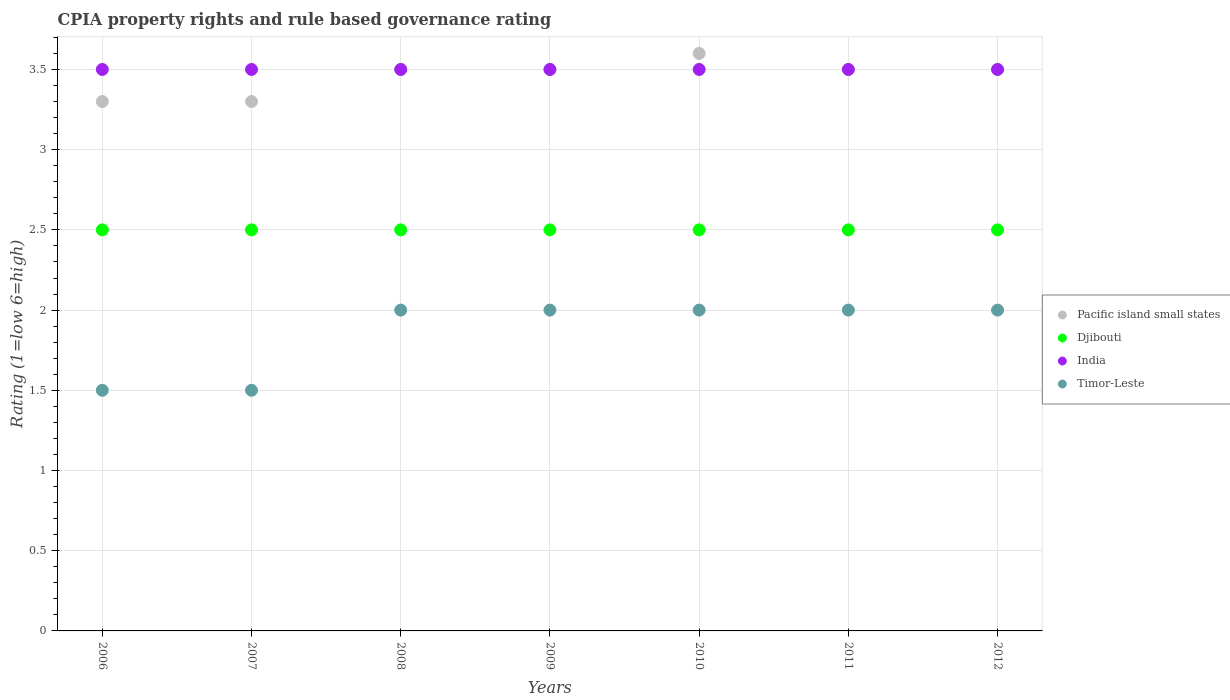Is the number of dotlines equal to the number of legend labels?
Your response must be concise. Yes. Across all years, what is the minimum CPIA rating in Djibouti?
Ensure brevity in your answer.  2.5. In which year was the CPIA rating in Pacific island small states minimum?
Offer a terse response. 2006. What is the total CPIA rating in Pacific island small states in the graph?
Your response must be concise. 24.2. What is the difference between the CPIA rating in India in 2010 and that in 2011?
Provide a succinct answer. 0. What is the difference between the CPIA rating in Timor-Leste in 2012 and the CPIA rating in Pacific island small states in 2007?
Ensure brevity in your answer.  -1.3. In how many years, is the CPIA rating in India greater than 2.4?
Make the answer very short. 7. What is the ratio of the CPIA rating in Timor-Leste in 2006 to that in 2011?
Offer a terse response. 0.75. Is the CPIA rating in India in 2008 less than that in 2011?
Ensure brevity in your answer.  No. What is the difference between the highest and the second highest CPIA rating in Pacific island small states?
Keep it short and to the point. 0.1. In how many years, is the CPIA rating in India greater than the average CPIA rating in India taken over all years?
Keep it short and to the point. 0. Is the sum of the CPIA rating in India in 2006 and 2008 greater than the maximum CPIA rating in Timor-Leste across all years?
Your answer should be compact. Yes. Is it the case that in every year, the sum of the CPIA rating in Timor-Leste and CPIA rating in Pacific island small states  is greater than the sum of CPIA rating in Djibouti and CPIA rating in India?
Your response must be concise. No. Is it the case that in every year, the sum of the CPIA rating in Timor-Leste and CPIA rating in Djibouti  is greater than the CPIA rating in India?
Keep it short and to the point. Yes. Is the CPIA rating in Djibouti strictly greater than the CPIA rating in Pacific island small states over the years?
Give a very brief answer. No. Is the CPIA rating in Timor-Leste strictly less than the CPIA rating in India over the years?
Give a very brief answer. Yes. How many years are there in the graph?
Offer a very short reply. 7. Are the values on the major ticks of Y-axis written in scientific E-notation?
Provide a succinct answer. No. Does the graph contain any zero values?
Offer a terse response. No. Where does the legend appear in the graph?
Provide a succinct answer. Center right. What is the title of the graph?
Make the answer very short. CPIA property rights and rule based governance rating. Does "South Sudan" appear as one of the legend labels in the graph?
Give a very brief answer. No. What is the Rating (1=low 6=high) of Pacific island small states in 2006?
Ensure brevity in your answer.  3.3. What is the Rating (1=low 6=high) of Timor-Leste in 2006?
Offer a very short reply. 1.5. What is the Rating (1=low 6=high) in Djibouti in 2007?
Your answer should be compact. 2.5. What is the Rating (1=low 6=high) in India in 2007?
Give a very brief answer. 3.5. What is the Rating (1=low 6=high) of Timor-Leste in 2007?
Give a very brief answer. 1.5. What is the Rating (1=low 6=high) of Djibouti in 2008?
Your answer should be compact. 2.5. What is the Rating (1=low 6=high) of India in 2008?
Your response must be concise. 3.5. What is the Rating (1=low 6=high) of Timor-Leste in 2008?
Offer a terse response. 2. What is the Rating (1=low 6=high) in Pacific island small states in 2009?
Your answer should be compact. 3.5. What is the Rating (1=low 6=high) in India in 2009?
Offer a very short reply. 3.5. What is the Rating (1=low 6=high) of Timor-Leste in 2010?
Offer a very short reply. 2. What is the Rating (1=low 6=high) of Pacific island small states in 2011?
Your answer should be compact. 3.5. What is the Rating (1=low 6=high) of India in 2011?
Offer a terse response. 3.5. What is the Rating (1=low 6=high) of Timor-Leste in 2011?
Provide a short and direct response. 2. What is the Rating (1=low 6=high) in Timor-Leste in 2012?
Ensure brevity in your answer.  2. Across all years, what is the maximum Rating (1=low 6=high) in India?
Provide a succinct answer. 3.5. What is the total Rating (1=low 6=high) of Pacific island small states in the graph?
Make the answer very short. 24.2. What is the total Rating (1=low 6=high) of Djibouti in the graph?
Provide a succinct answer. 17.5. What is the total Rating (1=low 6=high) in India in the graph?
Give a very brief answer. 24.5. What is the total Rating (1=low 6=high) of Timor-Leste in the graph?
Offer a very short reply. 13. What is the difference between the Rating (1=low 6=high) of India in 2006 and that in 2008?
Ensure brevity in your answer.  0. What is the difference between the Rating (1=low 6=high) in Pacific island small states in 2006 and that in 2009?
Your answer should be compact. -0.2. What is the difference between the Rating (1=low 6=high) of India in 2006 and that in 2009?
Your answer should be very brief. 0. What is the difference between the Rating (1=low 6=high) in Pacific island small states in 2006 and that in 2010?
Your answer should be compact. -0.3. What is the difference between the Rating (1=low 6=high) of Djibouti in 2006 and that in 2010?
Ensure brevity in your answer.  0. What is the difference between the Rating (1=low 6=high) in Pacific island small states in 2006 and that in 2011?
Make the answer very short. -0.2. What is the difference between the Rating (1=low 6=high) of Djibouti in 2006 and that in 2011?
Your answer should be compact. 0. What is the difference between the Rating (1=low 6=high) in India in 2006 and that in 2011?
Offer a very short reply. 0. What is the difference between the Rating (1=low 6=high) in Djibouti in 2006 and that in 2012?
Keep it short and to the point. 0. What is the difference between the Rating (1=low 6=high) of India in 2006 and that in 2012?
Offer a terse response. 0. What is the difference between the Rating (1=low 6=high) of Timor-Leste in 2006 and that in 2012?
Provide a succinct answer. -0.5. What is the difference between the Rating (1=low 6=high) in Pacific island small states in 2007 and that in 2008?
Your answer should be very brief. -0.2. What is the difference between the Rating (1=low 6=high) of India in 2007 and that in 2008?
Provide a short and direct response. 0. What is the difference between the Rating (1=low 6=high) in India in 2007 and that in 2009?
Provide a short and direct response. 0. What is the difference between the Rating (1=low 6=high) of Pacific island small states in 2007 and that in 2010?
Give a very brief answer. -0.3. What is the difference between the Rating (1=low 6=high) in Djibouti in 2007 and that in 2010?
Your answer should be compact. 0. What is the difference between the Rating (1=low 6=high) of India in 2007 and that in 2010?
Your answer should be compact. 0. What is the difference between the Rating (1=low 6=high) of Pacific island small states in 2007 and that in 2011?
Offer a terse response. -0.2. What is the difference between the Rating (1=low 6=high) of Djibouti in 2007 and that in 2011?
Provide a succinct answer. 0. What is the difference between the Rating (1=low 6=high) of Pacific island small states in 2007 and that in 2012?
Make the answer very short. -0.2. What is the difference between the Rating (1=low 6=high) of India in 2007 and that in 2012?
Offer a very short reply. 0. What is the difference between the Rating (1=low 6=high) of Timor-Leste in 2007 and that in 2012?
Your answer should be very brief. -0.5. What is the difference between the Rating (1=low 6=high) in Pacific island small states in 2008 and that in 2009?
Ensure brevity in your answer.  0. What is the difference between the Rating (1=low 6=high) of Djibouti in 2008 and that in 2009?
Make the answer very short. 0. What is the difference between the Rating (1=low 6=high) in India in 2008 and that in 2009?
Keep it short and to the point. 0. What is the difference between the Rating (1=low 6=high) of Timor-Leste in 2008 and that in 2009?
Ensure brevity in your answer.  0. What is the difference between the Rating (1=low 6=high) of Djibouti in 2008 and that in 2010?
Give a very brief answer. 0. What is the difference between the Rating (1=low 6=high) in Pacific island small states in 2008 and that in 2011?
Provide a short and direct response. 0. What is the difference between the Rating (1=low 6=high) of Djibouti in 2008 and that in 2011?
Your response must be concise. 0. What is the difference between the Rating (1=low 6=high) of India in 2008 and that in 2011?
Make the answer very short. 0. What is the difference between the Rating (1=low 6=high) in Pacific island small states in 2008 and that in 2012?
Your response must be concise. 0. What is the difference between the Rating (1=low 6=high) in Djibouti in 2008 and that in 2012?
Provide a short and direct response. 0. What is the difference between the Rating (1=low 6=high) in Pacific island small states in 2009 and that in 2011?
Offer a terse response. 0. What is the difference between the Rating (1=low 6=high) of Djibouti in 2009 and that in 2011?
Give a very brief answer. 0. What is the difference between the Rating (1=low 6=high) of India in 2009 and that in 2011?
Make the answer very short. 0. What is the difference between the Rating (1=low 6=high) of Pacific island small states in 2009 and that in 2012?
Make the answer very short. 0. What is the difference between the Rating (1=low 6=high) of Djibouti in 2009 and that in 2012?
Your response must be concise. 0. What is the difference between the Rating (1=low 6=high) of Timor-Leste in 2009 and that in 2012?
Provide a succinct answer. 0. What is the difference between the Rating (1=low 6=high) of Pacific island small states in 2010 and that in 2011?
Offer a very short reply. 0.1. What is the difference between the Rating (1=low 6=high) in Timor-Leste in 2010 and that in 2011?
Offer a very short reply. 0. What is the difference between the Rating (1=low 6=high) of Pacific island small states in 2010 and that in 2012?
Your answer should be compact. 0.1. What is the difference between the Rating (1=low 6=high) in Djibouti in 2010 and that in 2012?
Keep it short and to the point. 0. What is the difference between the Rating (1=low 6=high) of India in 2010 and that in 2012?
Your response must be concise. 0. What is the difference between the Rating (1=low 6=high) of Timor-Leste in 2010 and that in 2012?
Offer a terse response. 0. What is the difference between the Rating (1=low 6=high) of Pacific island small states in 2011 and that in 2012?
Provide a succinct answer. 0. What is the difference between the Rating (1=low 6=high) of India in 2011 and that in 2012?
Provide a short and direct response. 0. What is the difference between the Rating (1=low 6=high) of Pacific island small states in 2006 and the Rating (1=low 6=high) of Djibouti in 2007?
Offer a terse response. 0.8. What is the difference between the Rating (1=low 6=high) of Pacific island small states in 2006 and the Rating (1=low 6=high) of India in 2007?
Keep it short and to the point. -0.2. What is the difference between the Rating (1=low 6=high) in Djibouti in 2006 and the Rating (1=low 6=high) in India in 2007?
Ensure brevity in your answer.  -1. What is the difference between the Rating (1=low 6=high) of Djibouti in 2006 and the Rating (1=low 6=high) of Timor-Leste in 2008?
Keep it short and to the point. 0.5. What is the difference between the Rating (1=low 6=high) of Djibouti in 2006 and the Rating (1=low 6=high) of Timor-Leste in 2009?
Provide a short and direct response. 0.5. What is the difference between the Rating (1=low 6=high) of India in 2006 and the Rating (1=low 6=high) of Timor-Leste in 2009?
Ensure brevity in your answer.  1.5. What is the difference between the Rating (1=low 6=high) of Pacific island small states in 2006 and the Rating (1=low 6=high) of Djibouti in 2010?
Ensure brevity in your answer.  0.8. What is the difference between the Rating (1=low 6=high) in Pacific island small states in 2006 and the Rating (1=low 6=high) in Djibouti in 2011?
Provide a short and direct response. 0.8. What is the difference between the Rating (1=low 6=high) of Pacific island small states in 2006 and the Rating (1=low 6=high) of India in 2011?
Keep it short and to the point. -0.2. What is the difference between the Rating (1=low 6=high) of Djibouti in 2006 and the Rating (1=low 6=high) of Timor-Leste in 2011?
Provide a succinct answer. 0.5. What is the difference between the Rating (1=low 6=high) in Pacific island small states in 2006 and the Rating (1=low 6=high) in Djibouti in 2012?
Provide a succinct answer. 0.8. What is the difference between the Rating (1=low 6=high) of Pacific island small states in 2006 and the Rating (1=low 6=high) of India in 2012?
Ensure brevity in your answer.  -0.2. What is the difference between the Rating (1=low 6=high) in Djibouti in 2006 and the Rating (1=low 6=high) in India in 2012?
Provide a succinct answer. -1. What is the difference between the Rating (1=low 6=high) of Djibouti in 2006 and the Rating (1=low 6=high) of Timor-Leste in 2012?
Ensure brevity in your answer.  0.5. What is the difference between the Rating (1=low 6=high) of India in 2006 and the Rating (1=low 6=high) of Timor-Leste in 2012?
Keep it short and to the point. 1.5. What is the difference between the Rating (1=low 6=high) of Pacific island small states in 2007 and the Rating (1=low 6=high) of Djibouti in 2008?
Provide a succinct answer. 0.8. What is the difference between the Rating (1=low 6=high) of Djibouti in 2007 and the Rating (1=low 6=high) of Timor-Leste in 2008?
Keep it short and to the point. 0.5. What is the difference between the Rating (1=low 6=high) of Pacific island small states in 2007 and the Rating (1=low 6=high) of Timor-Leste in 2009?
Provide a short and direct response. 1.3. What is the difference between the Rating (1=low 6=high) in Pacific island small states in 2007 and the Rating (1=low 6=high) in Djibouti in 2010?
Keep it short and to the point. 0.8. What is the difference between the Rating (1=low 6=high) in Pacific island small states in 2007 and the Rating (1=low 6=high) in India in 2010?
Your response must be concise. -0.2. What is the difference between the Rating (1=low 6=high) of Djibouti in 2007 and the Rating (1=low 6=high) of India in 2010?
Offer a terse response. -1. What is the difference between the Rating (1=low 6=high) in Djibouti in 2007 and the Rating (1=low 6=high) in Timor-Leste in 2010?
Provide a short and direct response. 0.5. What is the difference between the Rating (1=low 6=high) in India in 2007 and the Rating (1=low 6=high) in Timor-Leste in 2010?
Your answer should be compact. 1.5. What is the difference between the Rating (1=low 6=high) of Pacific island small states in 2007 and the Rating (1=low 6=high) of Djibouti in 2012?
Your answer should be compact. 0.8. What is the difference between the Rating (1=low 6=high) of Pacific island small states in 2007 and the Rating (1=low 6=high) of India in 2012?
Ensure brevity in your answer.  -0.2. What is the difference between the Rating (1=low 6=high) of India in 2007 and the Rating (1=low 6=high) of Timor-Leste in 2012?
Make the answer very short. 1.5. What is the difference between the Rating (1=low 6=high) in Pacific island small states in 2008 and the Rating (1=low 6=high) in Djibouti in 2009?
Your answer should be very brief. 1. What is the difference between the Rating (1=low 6=high) of Pacific island small states in 2008 and the Rating (1=low 6=high) of Timor-Leste in 2009?
Ensure brevity in your answer.  1.5. What is the difference between the Rating (1=low 6=high) of Djibouti in 2008 and the Rating (1=low 6=high) of Timor-Leste in 2009?
Your answer should be very brief. 0.5. What is the difference between the Rating (1=low 6=high) in Pacific island small states in 2008 and the Rating (1=low 6=high) in Djibouti in 2010?
Your answer should be compact. 1. What is the difference between the Rating (1=low 6=high) of Pacific island small states in 2008 and the Rating (1=low 6=high) of Timor-Leste in 2010?
Make the answer very short. 1.5. What is the difference between the Rating (1=low 6=high) of Pacific island small states in 2008 and the Rating (1=low 6=high) of India in 2011?
Make the answer very short. 0. What is the difference between the Rating (1=low 6=high) in Pacific island small states in 2008 and the Rating (1=low 6=high) in Timor-Leste in 2011?
Your answer should be compact. 1.5. What is the difference between the Rating (1=low 6=high) in Djibouti in 2008 and the Rating (1=low 6=high) in Timor-Leste in 2011?
Keep it short and to the point. 0.5. What is the difference between the Rating (1=low 6=high) in India in 2008 and the Rating (1=low 6=high) in Timor-Leste in 2011?
Keep it short and to the point. 1.5. What is the difference between the Rating (1=low 6=high) in Pacific island small states in 2008 and the Rating (1=low 6=high) in Djibouti in 2012?
Make the answer very short. 1. What is the difference between the Rating (1=low 6=high) in Djibouti in 2008 and the Rating (1=low 6=high) in India in 2012?
Offer a terse response. -1. What is the difference between the Rating (1=low 6=high) in Djibouti in 2008 and the Rating (1=low 6=high) in Timor-Leste in 2012?
Your answer should be compact. 0.5. What is the difference between the Rating (1=low 6=high) of India in 2008 and the Rating (1=low 6=high) of Timor-Leste in 2012?
Give a very brief answer. 1.5. What is the difference between the Rating (1=low 6=high) of Pacific island small states in 2009 and the Rating (1=low 6=high) of Djibouti in 2010?
Provide a succinct answer. 1. What is the difference between the Rating (1=low 6=high) in Pacific island small states in 2009 and the Rating (1=low 6=high) in India in 2010?
Provide a short and direct response. 0. What is the difference between the Rating (1=low 6=high) of Pacific island small states in 2009 and the Rating (1=low 6=high) of Timor-Leste in 2010?
Your answer should be compact. 1.5. What is the difference between the Rating (1=low 6=high) in Djibouti in 2009 and the Rating (1=low 6=high) in India in 2010?
Ensure brevity in your answer.  -1. What is the difference between the Rating (1=low 6=high) in Pacific island small states in 2009 and the Rating (1=low 6=high) in India in 2012?
Provide a succinct answer. 0. What is the difference between the Rating (1=low 6=high) of Pacific island small states in 2009 and the Rating (1=low 6=high) of Timor-Leste in 2012?
Offer a terse response. 1.5. What is the difference between the Rating (1=low 6=high) in Djibouti in 2009 and the Rating (1=low 6=high) in India in 2012?
Your answer should be very brief. -1. What is the difference between the Rating (1=low 6=high) of Djibouti in 2009 and the Rating (1=low 6=high) of Timor-Leste in 2012?
Your answer should be compact. 0.5. What is the difference between the Rating (1=low 6=high) of India in 2009 and the Rating (1=low 6=high) of Timor-Leste in 2012?
Your answer should be very brief. 1.5. What is the difference between the Rating (1=low 6=high) in Pacific island small states in 2010 and the Rating (1=low 6=high) in Djibouti in 2011?
Keep it short and to the point. 1.1. What is the difference between the Rating (1=low 6=high) in Djibouti in 2010 and the Rating (1=low 6=high) in Timor-Leste in 2011?
Ensure brevity in your answer.  0.5. What is the difference between the Rating (1=low 6=high) in Pacific island small states in 2010 and the Rating (1=low 6=high) in India in 2012?
Provide a succinct answer. 0.1. What is the difference between the Rating (1=low 6=high) in Djibouti in 2010 and the Rating (1=low 6=high) in Timor-Leste in 2012?
Keep it short and to the point. 0.5. What is the difference between the Rating (1=low 6=high) of India in 2010 and the Rating (1=low 6=high) of Timor-Leste in 2012?
Your answer should be compact. 1.5. What is the difference between the Rating (1=low 6=high) in Pacific island small states in 2011 and the Rating (1=low 6=high) in Timor-Leste in 2012?
Keep it short and to the point. 1.5. What is the difference between the Rating (1=low 6=high) in Djibouti in 2011 and the Rating (1=low 6=high) in Timor-Leste in 2012?
Provide a short and direct response. 0.5. What is the average Rating (1=low 6=high) in Pacific island small states per year?
Offer a very short reply. 3.46. What is the average Rating (1=low 6=high) in Djibouti per year?
Make the answer very short. 2.5. What is the average Rating (1=low 6=high) in India per year?
Offer a very short reply. 3.5. What is the average Rating (1=low 6=high) in Timor-Leste per year?
Your response must be concise. 1.86. In the year 2007, what is the difference between the Rating (1=low 6=high) of Pacific island small states and Rating (1=low 6=high) of Timor-Leste?
Keep it short and to the point. 1.8. In the year 2007, what is the difference between the Rating (1=low 6=high) of Djibouti and Rating (1=low 6=high) of India?
Provide a short and direct response. -1. In the year 2007, what is the difference between the Rating (1=low 6=high) of Djibouti and Rating (1=low 6=high) of Timor-Leste?
Your answer should be compact. 1. In the year 2007, what is the difference between the Rating (1=low 6=high) in India and Rating (1=low 6=high) in Timor-Leste?
Provide a short and direct response. 2. In the year 2008, what is the difference between the Rating (1=low 6=high) in Pacific island small states and Rating (1=low 6=high) in Djibouti?
Make the answer very short. 1. In the year 2008, what is the difference between the Rating (1=low 6=high) of Pacific island small states and Rating (1=low 6=high) of India?
Provide a succinct answer. 0. In the year 2008, what is the difference between the Rating (1=low 6=high) in Pacific island small states and Rating (1=low 6=high) in Timor-Leste?
Keep it short and to the point. 1.5. In the year 2008, what is the difference between the Rating (1=low 6=high) in Djibouti and Rating (1=low 6=high) in Timor-Leste?
Offer a terse response. 0.5. In the year 2008, what is the difference between the Rating (1=low 6=high) in India and Rating (1=low 6=high) in Timor-Leste?
Ensure brevity in your answer.  1.5. In the year 2009, what is the difference between the Rating (1=low 6=high) in Pacific island small states and Rating (1=low 6=high) in Djibouti?
Ensure brevity in your answer.  1. In the year 2009, what is the difference between the Rating (1=low 6=high) of Pacific island small states and Rating (1=low 6=high) of India?
Keep it short and to the point. 0. In the year 2009, what is the difference between the Rating (1=low 6=high) of Djibouti and Rating (1=low 6=high) of India?
Your answer should be compact. -1. In the year 2009, what is the difference between the Rating (1=low 6=high) of Djibouti and Rating (1=low 6=high) of Timor-Leste?
Keep it short and to the point. 0.5. In the year 2009, what is the difference between the Rating (1=low 6=high) in India and Rating (1=low 6=high) in Timor-Leste?
Your response must be concise. 1.5. In the year 2010, what is the difference between the Rating (1=low 6=high) of Djibouti and Rating (1=low 6=high) of India?
Offer a terse response. -1. In the year 2011, what is the difference between the Rating (1=low 6=high) in India and Rating (1=low 6=high) in Timor-Leste?
Your answer should be very brief. 1.5. In the year 2012, what is the difference between the Rating (1=low 6=high) in Pacific island small states and Rating (1=low 6=high) in India?
Offer a terse response. 0. What is the ratio of the Rating (1=low 6=high) in Djibouti in 2006 to that in 2007?
Your answer should be very brief. 1. What is the ratio of the Rating (1=low 6=high) in Timor-Leste in 2006 to that in 2007?
Your response must be concise. 1. What is the ratio of the Rating (1=low 6=high) in Pacific island small states in 2006 to that in 2008?
Provide a short and direct response. 0.94. What is the ratio of the Rating (1=low 6=high) in Djibouti in 2006 to that in 2008?
Give a very brief answer. 1. What is the ratio of the Rating (1=low 6=high) of Pacific island small states in 2006 to that in 2009?
Keep it short and to the point. 0.94. What is the ratio of the Rating (1=low 6=high) of Djibouti in 2006 to that in 2009?
Your answer should be very brief. 1. What is the ratio of the Rating (1=low 6=high) in Pacific island small states in 2006 to that in 2010?
Give a very brief answer. 0.92. What is the ratio of the Rating (1=low 6=high) in Pacific island small states in 2006 to that in 2011?
Keep it short and to the point. 0.94. What is the ratio of the Rating (1=low 6=high) in Djibouti in 2006 to that in 2011?
Your answer should be compact. 1. What is the ratio of the Rating (1=low 6=high) in Pacific island small states in 2006 to that in 2012?
Provide a succinct answer. 0.94. What is the ratio of the Rating (1=low 6=high) of Djibouti in 2006 to that in 2012?
Your response must be concise. 1. What is the ratio of the Rating (1=low 6=high) of India in 2006 to that in 2012?
Your response must be concise. 1. What is the ratio of the Rating (1=low 6=high) of Timor-Leste in 2006 to that in 2012?
Your answer should be compact. 0.75. What is the ratio of the Rating (1=low 6=high) in Pacific island small states in 2007 to that in 2008?
Ensure brevity in your answer.  0.94. What is the ratio of the Rating (1=low 6=high) of Timor-Leste in 2007 to that in 2008?
Provide a succinct answer. 0.75. What is the ratio of the Rating (1=low 6=high) in Pacific island small states in 2007 to that in 2009?
Provide a short and direct response. 0.94. What is the ratio of the Rating (1=low 6=high) in India in 2007 to that in 2009?
Make the answer very short. 1. What is the ratio of the Rating (1=low 6=high) in India in 2007 to that in 2010?
Provide a succinct answer. 1. What is the ratio of the Rating (1=low 6=high) of Pacific island small states in 2007 to that in 2011?
Provide a short and direct response. 0.94. What is the ratio of the Rating (1=low 6=high) of Pacific island small states in 2007 to that in 2012?
Your answer should be compact. 0.94. What is the ratio of the Rating (1=low 6=high) of Djibouti in 2007 to that in 2012?
Offer a terse response. 1. What is the ratio of the Rating (1=low 6=high) in India in 2007 to that in 2012?
Your answer should be compact. 1. What is the ratio of the Rating (1=low 6=high) in India in 2008 to that in 2009?
Ensure brevity in your answer.  1. What is the ratio of the Rating (1=low 6=high) of Pacific island small states in 2008 to that in 2010?
Offer a very short reply. 0.97. What is the ratio of the Rating (1=low 6=high) in Djibouti in 2008 to that in 2010?
Ensure brevity in your answer.  1. What is the ratio of the Rating (1=low 6=high) of Pacific island small states in 2008 to that in 2011?
Keep it short and to the point. 1. What is the ratio of the Rating (1=low 6=high) of Timor-Leste in 2008 to that in 2011?
Your response must be concise. 1. What is the ratio of the Rating (1=low 6=high) in Pacific island small states in 2008 to that in 2012?
Provide a succinct answer. 1. What is the ratio of the Rating (1=low 6=high) in India in 2008 to that in 2012?
Make the answer very short. 1. What is the ratio of the Rating (1=low 6=high) of Timor-Leste in 2008 to that in 2012?
Your answer should be very brief. 1. What is the ratio of the Rating (1=low 6=high) in Pacific island small states in 2009 to that in 2010?
Provide a succinct answer. 0.97. What is the ratio of the Rating (1=low 6=high) of Timor-Leste in 2009 to that in 2010?
Provide a succinct answer. 1. What is the ratio of the Rating (1=low 6=high) of India in 2009 to that in 2012?
Your answer should be compact. 1. What is the ratio of the Rating (1=low 6=high) in Pacific island small states in 2010 to that in 2011?
Ensure brevity in your answer.  1.03. What is the ratio of the Rating (1=low 6=high) in Djibouti in 2010 to that in 2011?
Your answer should be compact. 1. What is the ratio of the Rating (1=low 6=high) in Pacific island small states in 2010 to that in 2012?
Ensure brevity in your answer.  1.03. What is the ratio of the Rating (1=low 6=high) in Timor-Leste in 2010 to that in 2012?
Offer a very short reply. 1. What is the ratio of the Rating (1=low 6=high) of Pacific island small states in 2011 to that in 2012?
Make the answer very short. 1. What is the ratio of the Rating (1=low 6=high) in Djibouti in 2011 to that in 2012?
Offer a terse response. 1. What is the ratio of the Rating (1=low 6=high) of Timor-Leste in 2011 to that in 2012?
Your answer should be very brief. 1. What is the difference between the highest and the second highest Rating (1=low 6=high) of Pacific island small states?
Give a very brief answer. 0.1. What is the difference between the highest and the second highest Rating (1=low 6=high) in Timor-Leste?
Provide a short and direct response. 0. What is the difference between the highest and the lowest Rating (1=low 6=high) of India?
Provide a short and direct response. 0. What is the difference between the highest and the lowest Rating (1=low 6=high) in Timor-Leste?
Offer a terse response. 0.5. 